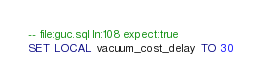<code> <loc_0><loc_0><loc_500><loc_500><_SQL_>-- file:guc.sql ln:108 expect:true
SET LOCAL vacuum_cost_delay TO 30
</code> 